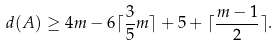Convert formula to latex. <formula><loc_0><loc_0><loc_500><loc_500>d ( A ) \geq 4 m - 6 \lceil \frac { 3 } { 5 } m \rceil + 5 + \lceil \frac { m - 1 } { 2 } \rceil .</formula> 